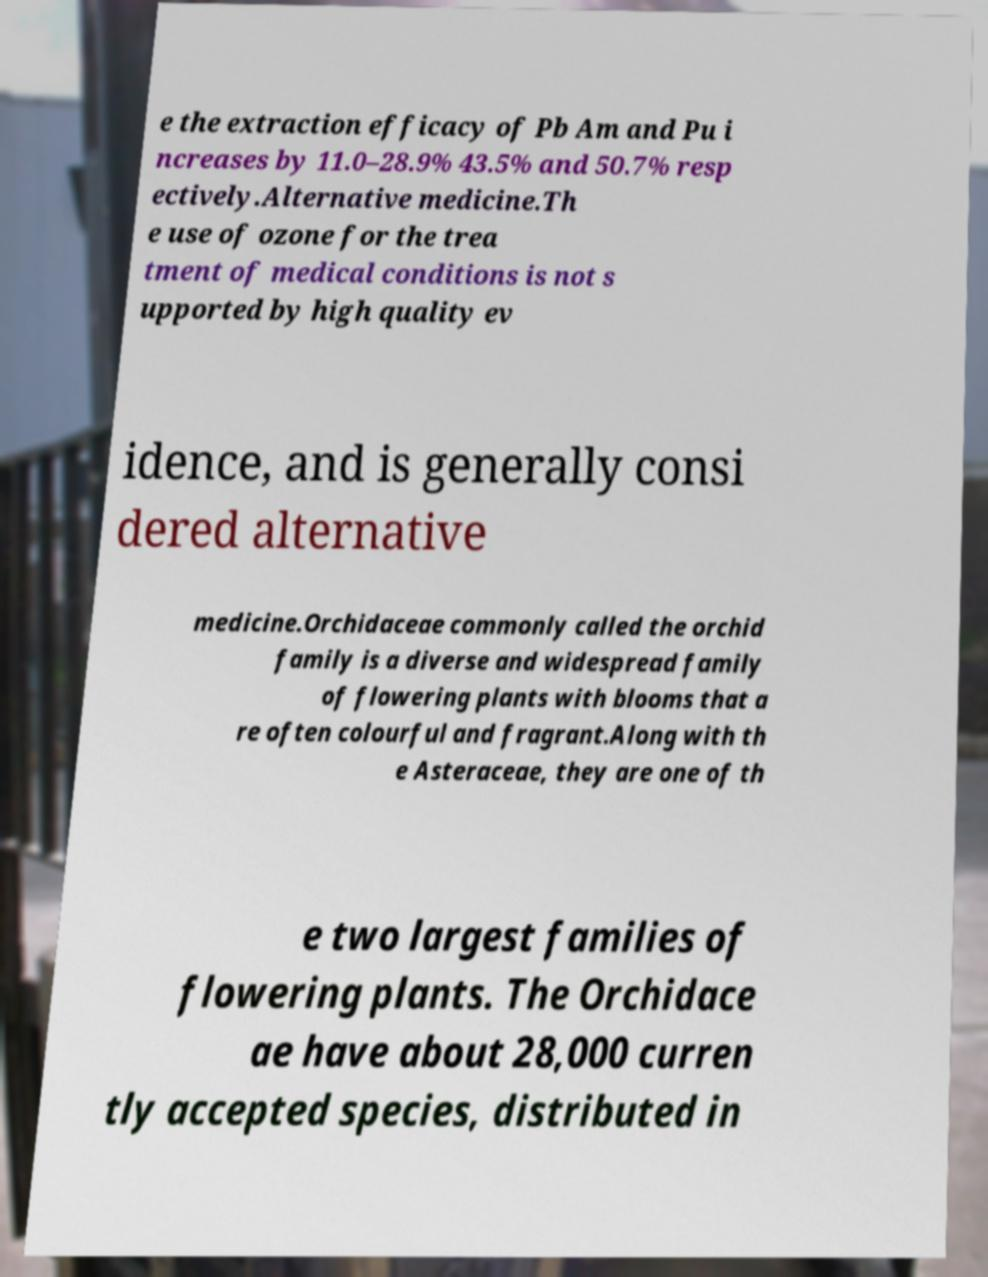I need the written content from this picture converted into text. Can you do that? e the extraction efficacy of Pb Am and Pu i ncreases by 11.0–28.9% 43.5% and 50.7% resp ectively.Alternative medicine.Th e use of ozone for the trea tment of medical conditions is not s upported by high quality ev idence, and is generally consi dered alternative medicine.Orchidaceae commonly called the orchid family is a diverse and widespread family of flowering plants with blooms that a re often colourful and fragrant.Along with th e Asteraceae, they are one of th e two largest families of flowering plants. The Orchidace ae have about 28,000 curren tly accepted species, distributed in 